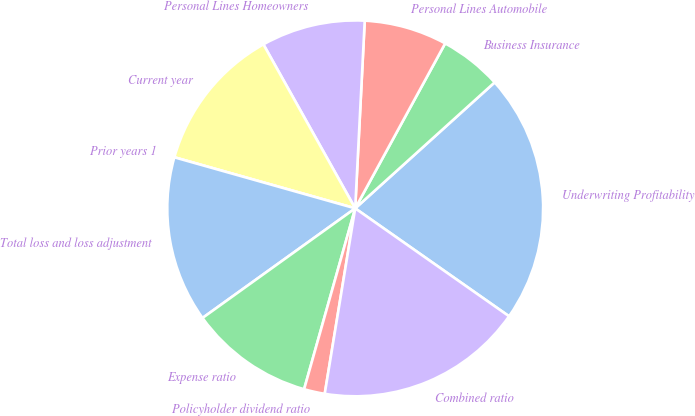Convert chart. <chart><loc_0><loc_0><loc_500><loc_500><pie_chart><fcel>Underwriting Profitability<fcel>Business Insurance<fcel>Personal Lines Automobile<fcel>Personal Lines Homeowners<fcel>Current year<fcel>Prior years 1<fcel>Total loss and loss adjustment<fcel>Expense ratio<fcel>Policyholder dividend ratio<fcel>Combined ratio<nl><fcel>21.43%<fcel>5.36%<fcel>7.14%<fcel>8.93%<fcel>12.5%<fcel>0.0%<fcel>14.29%<fcel>10.71%<fcel>1.79%<fcel>17.86%<nl></chart> 